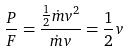<formula> <loc_0><loc_0><loc_500><loc_500>\frac { P } { F } = \frac { \frac { 1 } { 2 } \dot { m } v ^ { 2 } } { \dot { m } v } = \frac { 1 } { 2 } v</formula> 